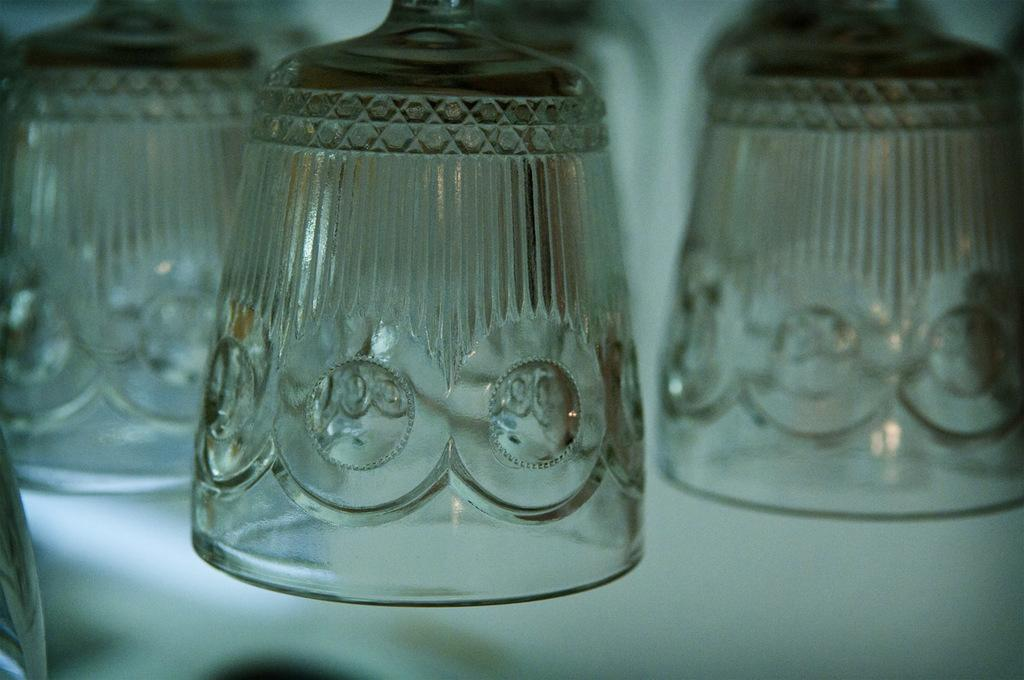What objects are present in the image? There are glasses in the image. What color is the background of the image? The background of the image is white. What type of caption is written on the glasses in the image? There is no caption written on the glasses in the image. Can you see any feathers or stockings in the image? There are no feathers or stockings present in the image. 